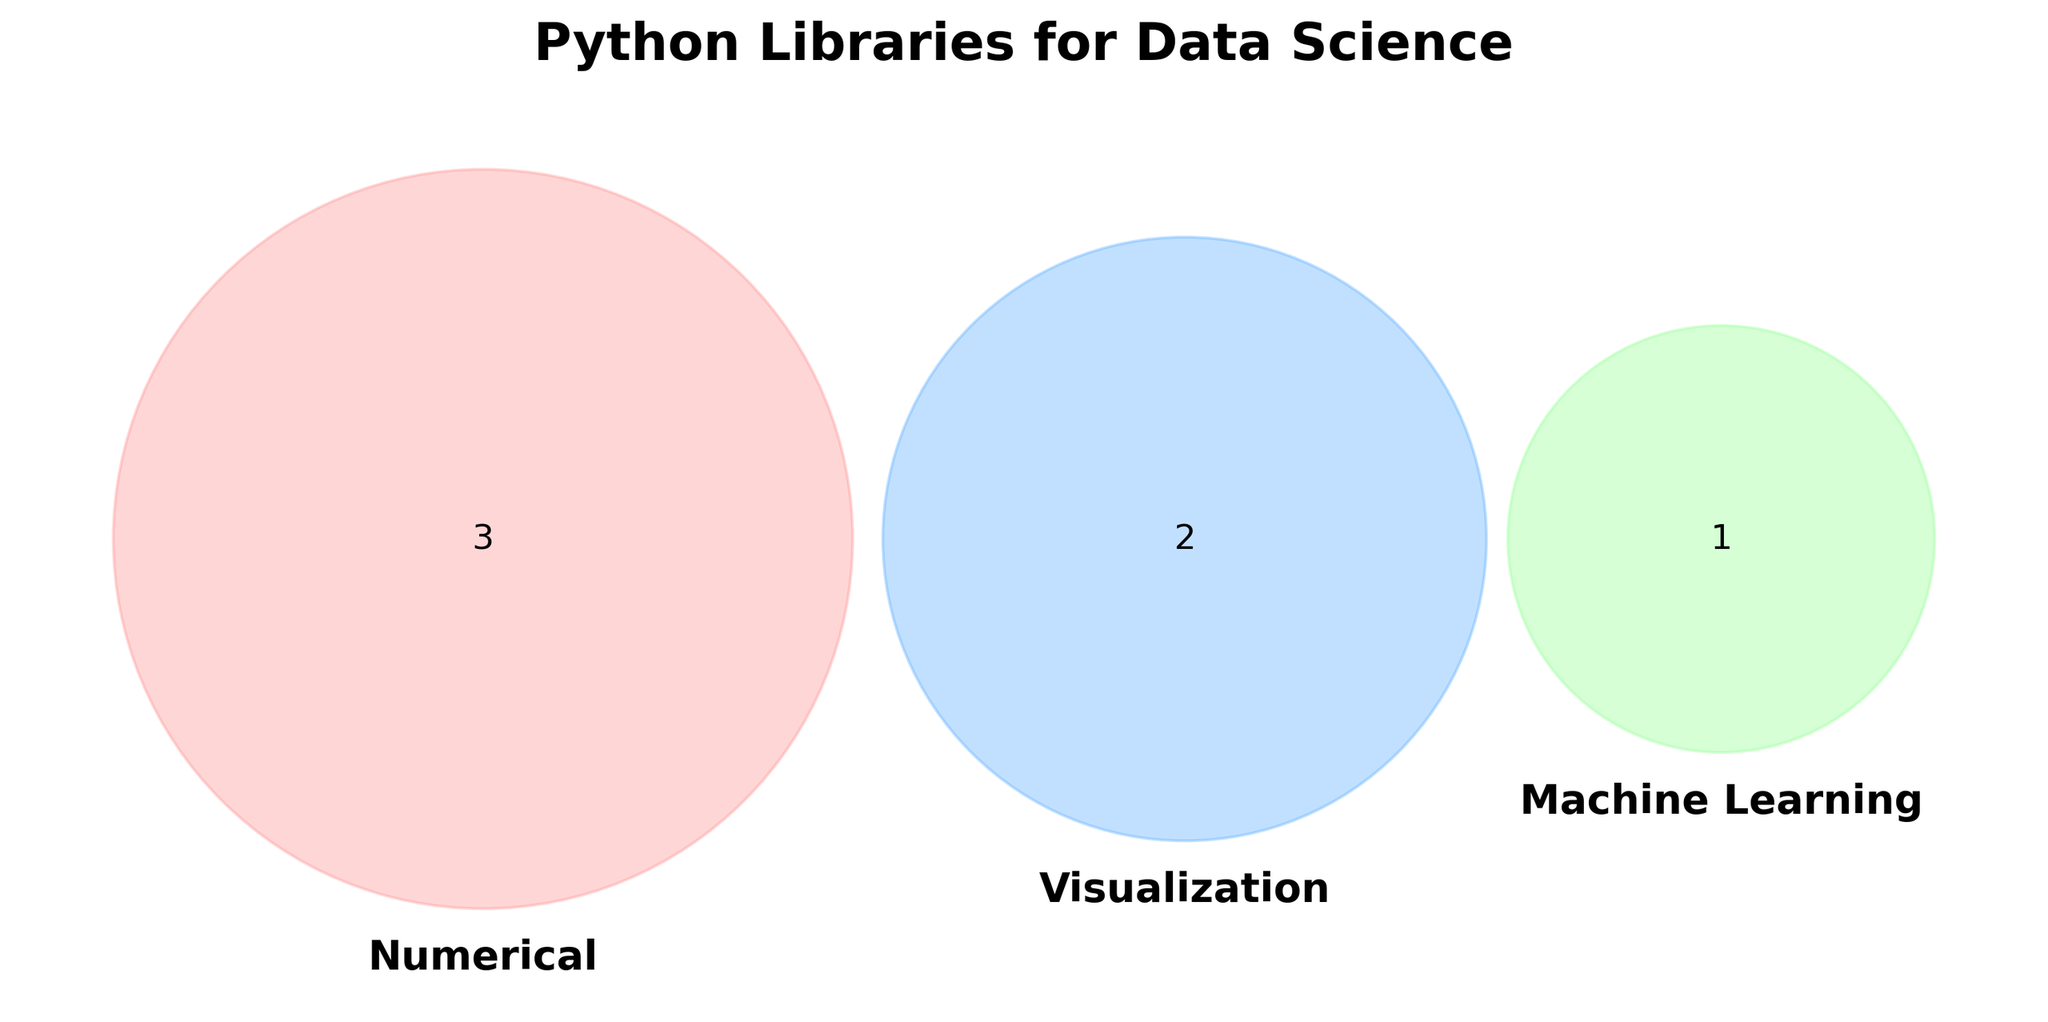What's the title of the figure? The title is located at the top center of the Venn diagram and gives an overview of the diagram's subject.
Answer: Python Libraries for Data Science How many categories are in the Venn diagram? The Venn diagram's labels indicate the number of categories represented by the circles.
Answer: Three What color represents the 'Numerical' category? The color of each category can be identified by looking at the color of the patches of the corresponding circle.
Answer: Light Red Which libraries are only associated with 'Machine Learning'? To find libraries unique to 'Machine Learning', check the section exclusive to the green circle.
Answer: TensorFlow Are there any libraries that are shared among 'Numerical', 'Visualization', and 'Machine Learning'? Look for intersections that cover all three sets in the Venn diagram.
Answer: No Which color denotes 'Visualization'? Identify the color by observing the circle labeled 'Visualization'.
Answer: Light Blue What is the font style of the set labels? The appearance of the text for set labels can be identified by their bold style and specific font choice.
Answer: Bold How many libraries are there in the 'Numerical' category? Count the number of elements in the intersection representing 'Numerical' only.
Answer: Three Are any libraries shared between 'Numerical' and 'Visualization'? Look at the overlapping section between the 'Numerical' and 'Visualization' circles.
Answer: No Which categories have shared libraries present? Observe the intersections where the sets overlap.
Answer: None 